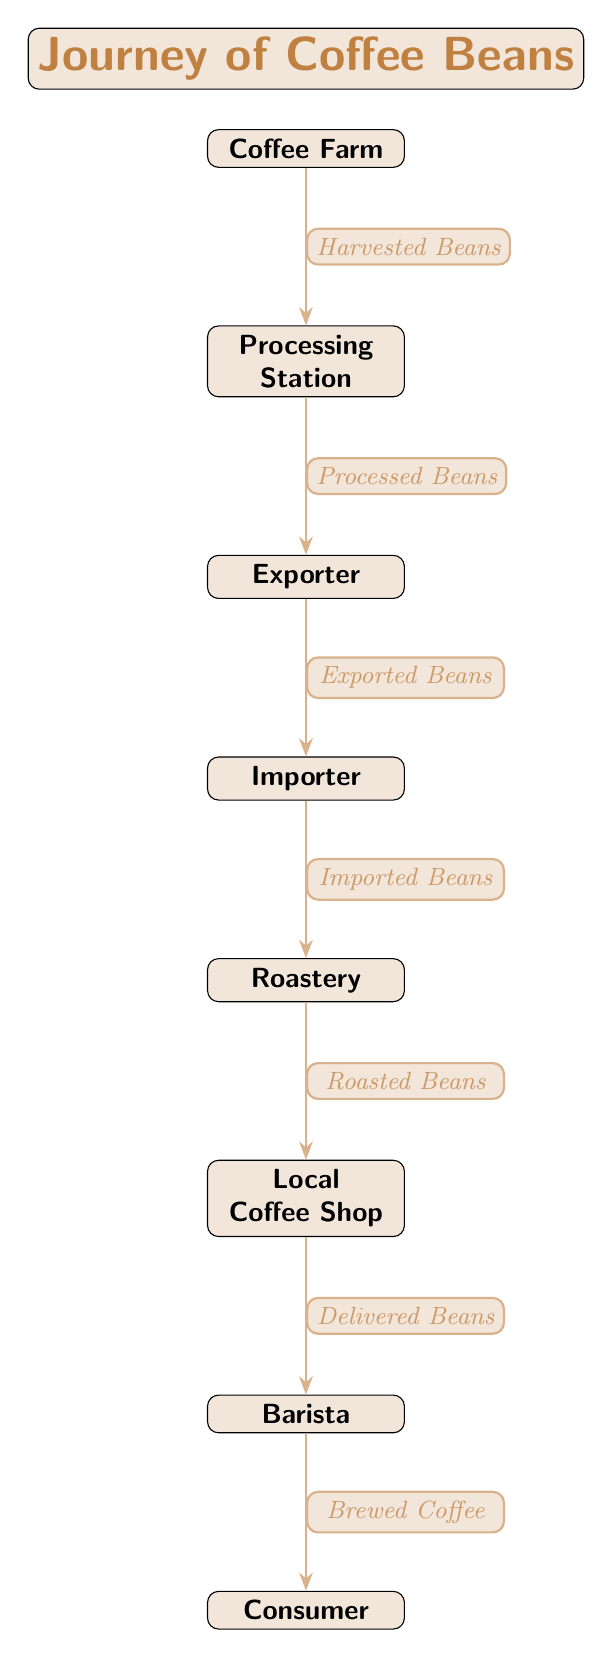What is the starting point of the coffee bean journey? The diagram indicates that the journey begins at the "Coffee Farm."
Answer: Coffee Farm How many nodes are in the diagram? By counting the distinct locations represented, we find there are 8 nodes in total.
Answer: 8 What is the first transformation applied to the coffee beans? The diagram shows that the first transformation is from "Harvested Beans" to "Processed Beans" at the Processing Station.
Answer: Processed Beans Which node comes after the Roastery? Following the flow in the diagram, the node that comes after the Roastery is the Local Coffee Shop.
Answer: Local Coffee Shop What is delivered to the Barista? According to the diagram, the Barista receives "Delivered Beans" from the Local Coffee Shop.
Answer: Delivered Beans What is the last step in the coffee bean journey? The final step in the journey, as depicted, is the transformation to "Brewed Coffee" for the Consumer by the Barista.
Answer: Brewed Coffee Which nodes represent entities that do not process the coffee beans? The nodes "Exporter," "Importer," and "Consumer" do not actively process the coffee beans but rather facilitate their journey or consume the final product.
Answer: Exporter, Importer, Consumer What type of beans reach the Local Coffee Shop from the Roastery? The diagram clearly identifies the beans arriving at the Local Coffee Shop from the Roastery as "Roasted Beans."
Answer: Roasted Beans 